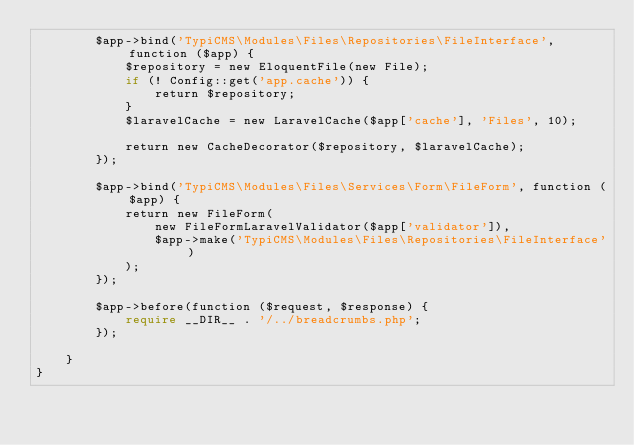Convert code to text. <code><loc_0><loc_0><loc_500><loc_500><_PHP_>        $app->bind('TypiCMS\Modules\Files\Repositories\FileInterface', function ($app) {
            $repository = new EloquentFile(new File);
            if (! Config::get('app.cache')) {
                return $repository;
            }
            $laravelCache = new LaravelCache($app['cache'], 'Files', 10);

            return new CacheDecorator($repository, $laravelCache);
        });

        $app->bind('TypiCMS\Modules\Files\Services\Form\FileForm', function ($app) {
            return new FileForm(
                new FileFormLaravelValidator($app['validator']),
                $app->make('TypiCMS\Modules\Files\Repositories\FileInterface')
            );
        });

        $app->before(function ($request, $response) {
            require __DIR__ . '/../breadcrumbs.php';
        });

    }
}
</code> 